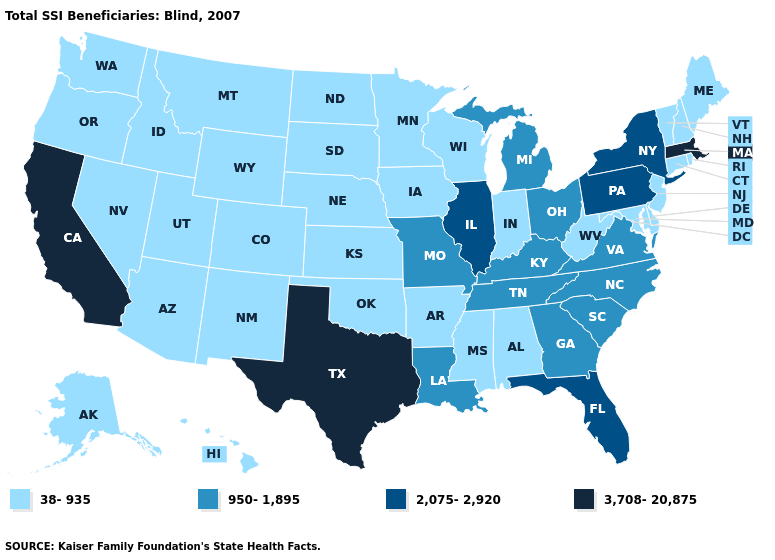Name the states that have a value in the range 3,708-20,875?
Keep it brief. California, Massachusetts, Texas. Does Illinois have the lowest value in the MidWest?
Short answer required. No. Name the states that have a value in the range 38-935?
Give a very brief answer. Alabama, Alaska, Arizona, Arkansas, Colorado, Connecticut, Delaware, Hawaii, Idaho, Indiana, Iowa, Kansas, Maine, Maryland, Minnesota, Mississippi, Montana, Nebraska, Nevada, New Hampshire, New Jersey, New Mexico, North Dakota, Oklahoma, Oregon, Rhode Island, South Dakota, Utah, Vermont, Washington, West Virginia, Wisconsin, Wyoming. Which states have the lowest value in the South?
Keep it brief. Alabama, Arkansas, Delaware, Maryland, Mississippi, Oklahoma, West Virginia. Among the states that border Iowa , does Wisconsin have the lowest value?
Short answer required. Yes. Does New Jersey have the lowest value in the Northeast?
Keep it brief. Yes. Which states have the lowest value in the USA?
Quick response, please. Alabama, Alaska, Arizona, Arkansas, Colorado, Connecticut, Delaware, Hawaii, Idaho, Indiana, Iowa, Kansas, Maine, Maryland, Minnesota, Mississippi, Montana, Nebraska, Nevada, New Hampshire, New Jersey, New Mexico, North Dakota, Oklahoma, Oregon, Rhode Island, South Dakota, Utah, Vermont, Washington, West Virginia, Wisconsin, Wyoming. Name the states that have a value in the range 950-1,895?
Be succinct. Georgia, Kentucky, Louisiana, Michigan, Missouri, North Carolina, Ohio, South Carolina, Tennessee, Virginia. Does California have the lowest value in the USA?
Write a very short answer. No. What is the value of Massachusetts?
Be succinct. 3,708-20,875. What is the value of Rhode Island?
Answer briefly. 38-935. Name the states that have a value in the range 2,075-2,920?
Quick response, please. Florida, Illinois, New York, Pennsylvania. Is the legend a continuous bar?
Concise answer only. No. Name the states that have a value in the range 950-1,895?
Write a very short answer. Georgia, Kentucky, Louisiana, Michigan, Missouri, North Carolina, Ohio, South Carolina, Tennessee, Virginia. Does Idaho have the lowest value in the West?
Write a very short answer. Yes. 